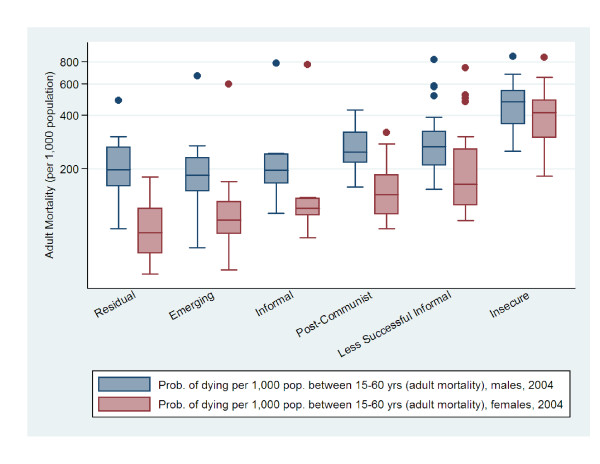Extract the information of this chart in json ```json
{
  "chart": {
    "title": "Adult Mortality",
    "x-axis": "Country type",
    "y-axis": "Probability of dying between 15-60 years old per 1,000 people"
  },
  "data": [
    {
      "country_type": "Residual",
      "prob_dying_male": [500, 600],
      "prob_dying_female": [200, 300]
    },
    {
      "country_type": "Emerging",
      "prob_dying_male": [200, 300],
      "prob_dying_female": [50, 100]
    },
    {
      "country_type": "Informal",
      "prob_dying_male": [200, 300],
      "prob_dying_female": [50, 150]
    },
    {
      "country_type": "Post-Communist",
      "prob_dying_male": [100, 200],
      "prob_dying_female": [50, 100]
    },
    {
      "country_type": "Less Successful",
      "prob_dying_male": [400, 600],
      "prob_dying_female": [200, 300]
    },
    {
      "country_type": "Insecure",
      "prob_dying_male": [500, 700],
      "prob_dying_female": [400, 500]
    }
  ]
}
``` 